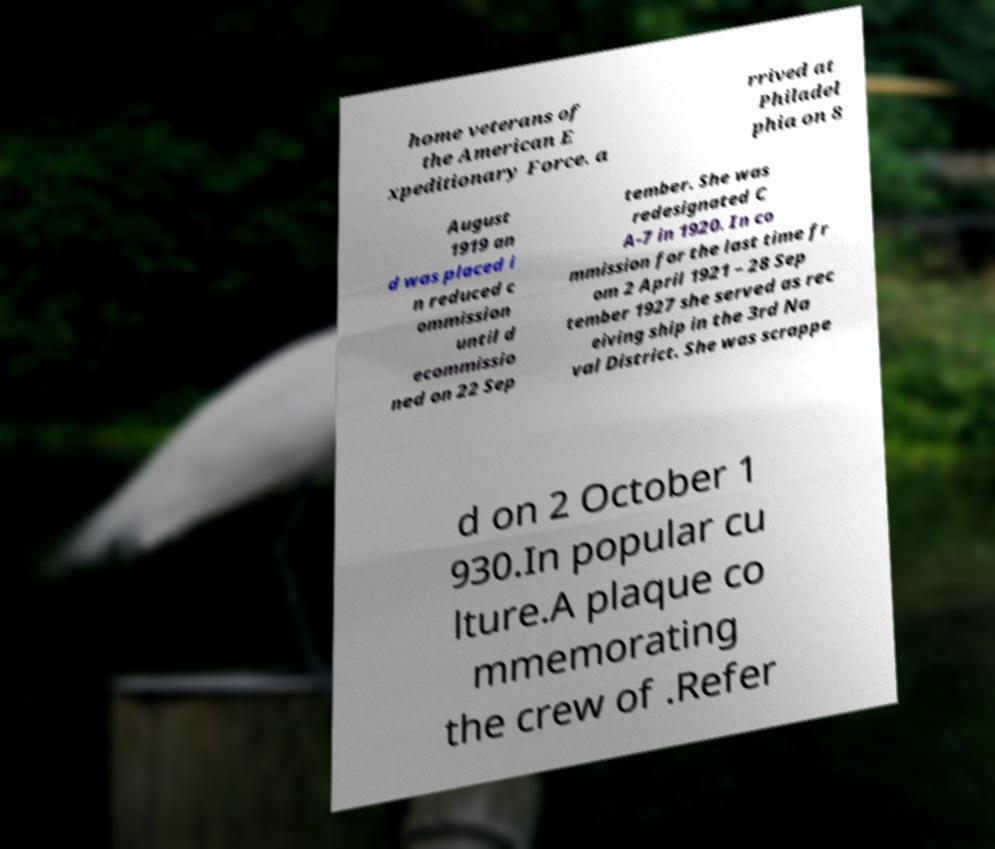Please identify and transcribe the text found in this image. home veterans of the American E xpeditionary Force. a rrived at Philadel phia on 8 August 1919 an d was placed i n reduced c ommission until d ecommissio ned on 22 Sep tember. She was redesignated C A-7 in 1920. In co mmission for the last time fr om 2 April 1921 – 28 Sep tember 1927 she served as rec eiving ship in the 3rd Na val District. She was scrappe d on 2 October 1 930.In popular cu lture.A plaque co mmemorating the crew of .Refer 